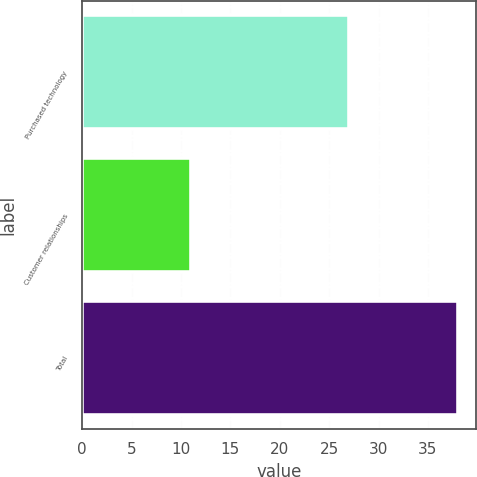Convert chart to OTSL. <chart><loc_0><loc_0><loc_500><loc_500><bar_chart><fcel>Purchased technology<fcel>Customer relationships<fcel>Total<nl><fcel>27<fcel>11<fcel>38<nl></chart> 